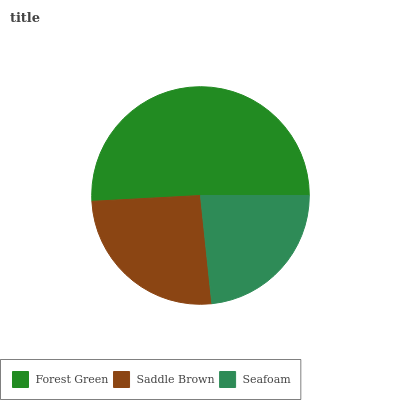Is Seafoam the minimum?
Answer yes or no. Yes. Is Forest Green the maximum?
Answer yes or no. Yes. Is Saddle Brown the minimum?
Answer yes or no. No. Is Saddle Brown the maximum?
Answer yes or no. No. Is Forest Green greater than Saddle Brown?
Answer yes or no. Yes. Is Saddle Brown less than Forest Green?
Answer yes or no. Yes. Is Saddle Brown greater than Forest Green?
Answer yes or no. No. Is Forest Green less than Saddle Brown?
Answer yes or no. No. Is Saddle Brown the high median?
Answer yes or no. Yes. Is Saddle Brown the low median?
Answer yes or no. Yes. Is Seafoam the high median?
Answer yes or no. No. Is Seafoam the low median?
Answer yes or no. No. 